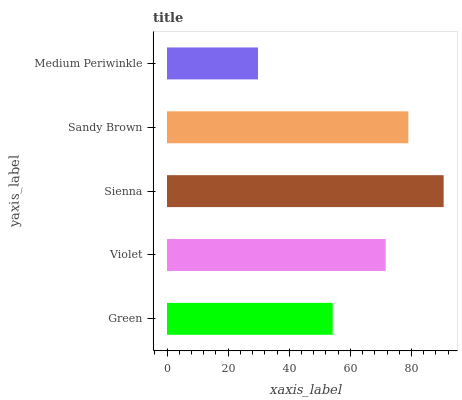Is Medium Periwinkle the minimum?
Answer yes or no. Yes. Is Sienna the maximum?
Answer yes or no. Yes. Is Violet the minimum?
Answer yes or no. No. Is Violet the maximum?
Answer yes or no. No. Is Violet greater than Green?
Answer yes or no. Yes. Is Green less than Violet?
Answer yes or no. Yes. Is Green greater than Violet?
Answer yes or no. No. Is Violet less than Green?
Answer yes or no. No. Is Violet the high median?
Answer yes or no. Yes. Is Violet the low median?
Answer yes or no. Yes. Is Green the high median?
Answer yes or no. No. Is Sienna the low median?
Answer yes or no. No. 